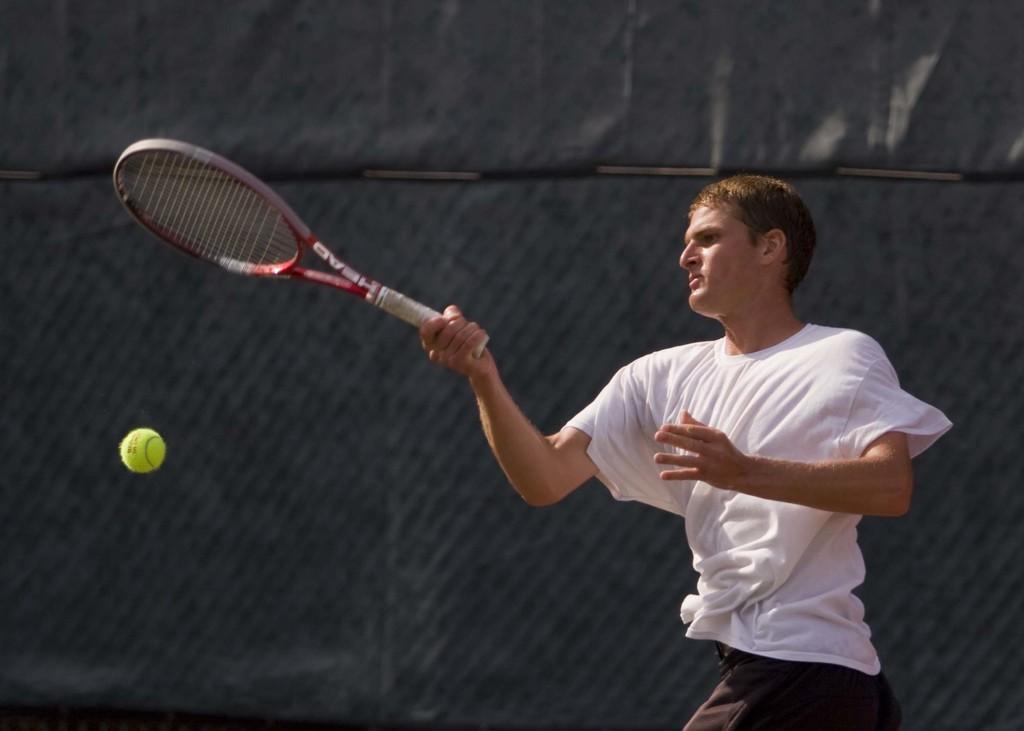How would you summarize this image in a sentence or two? In the image we can see a man standing, wearing clothes and holding a tennis bat in his hand. Here we can see a tennis ball and the background is dark. 